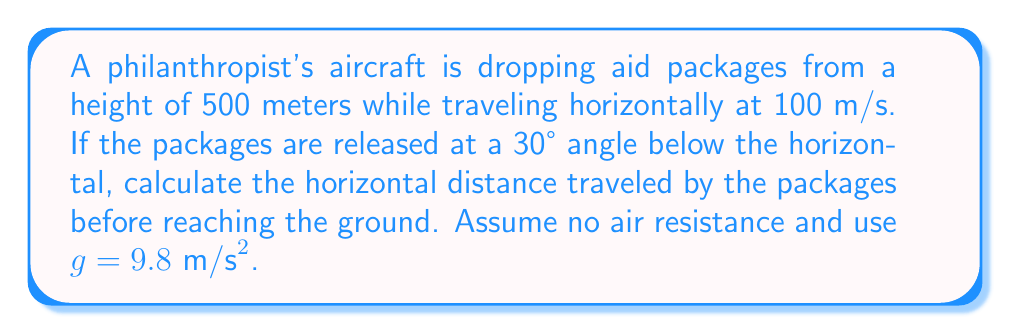Could you help me with this problem? To solve this problem, we'll use the equations of projectile motion and trigonometry. Let's break it down step-by-step:

1) First, let's identify the given information:
   - Initial height (h) = 500 m
   - Initial horizontal velocity (v₀ₓ) = 100 m/s
   - Angle below horizontal (θ) = 30°
   - Acceleration due to gravity (g) = 9.8 m/s²

2) We need to find the time it takes for the package to reach the ground. We can use the equation:
   $$y = y_0 + v_0y t - \frac{1}{2}gt^2$$

   Where y₀ = 500 m, and v₀y = v₀ sin(θ) = 100 sin(30°) = 50 m/s

3) Substituting these values:
   $$0 = 500 + 50t - \frac{1}{2}(9.8)t^2$$

4) Simplifying:
   $$4.9t^2 - 50t - 500 = 0$$

5) This is a quadratic equation. We can solve it using the quadratic formula:
   $$t = \frac{-b \pm \sqrt{b^2 - 4ac}}{2a}$$

   Where a = 4.9, b = -50, and c = -500

6) Solving this gives us:
   $$t \approx 11.54 \text{ seconds}$$

7) Now that we have the time, we can calculate the horizontal distance using:
   $$x = v_0x t$$

8) The horizontal component of the velocity is:
   $$v_{0x} = v_0 \cos(\theta) = 100 \cos(30°) = 100 * \frac{\sqrt{3}}{2} \approx 86.6 \text{ m/s}$$

9) Therefore, the horizontal distance is:
   $$x = 86.6 * 11.54 \approx 999.4 \text{ meters}$$
Answer: 999.4 meters 